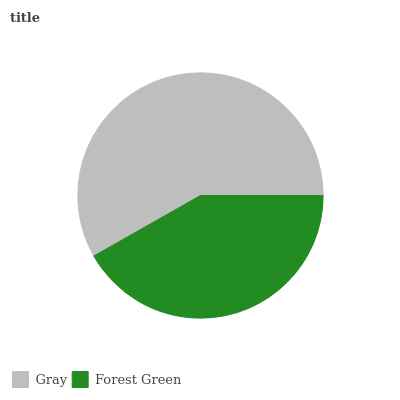Is Forest Green the minimum?
Answer yes or no. Yes. Is Gray the maximum?
Answer yes or no. Yes. Is Forest Green the maximum?
Answer yes or no. No. Is Gray greater than Forest Green?
Answer yes or no. Yes. Is Forest Green less than Gray?
Answer yes or no. Yes. Is Forest Green greater than Gray?
Answer yes or no. No. Is Gray less than Forest Green?
Answer yes or no. No. Is Gray the high median?
Answer yes or no. Yes. Is Forest Green the low median?
Answer yes or no. Yes. Is Forest Green the high median?
Answer yes or no. No. Is Gray the low median?
Answer yes or no. No. 